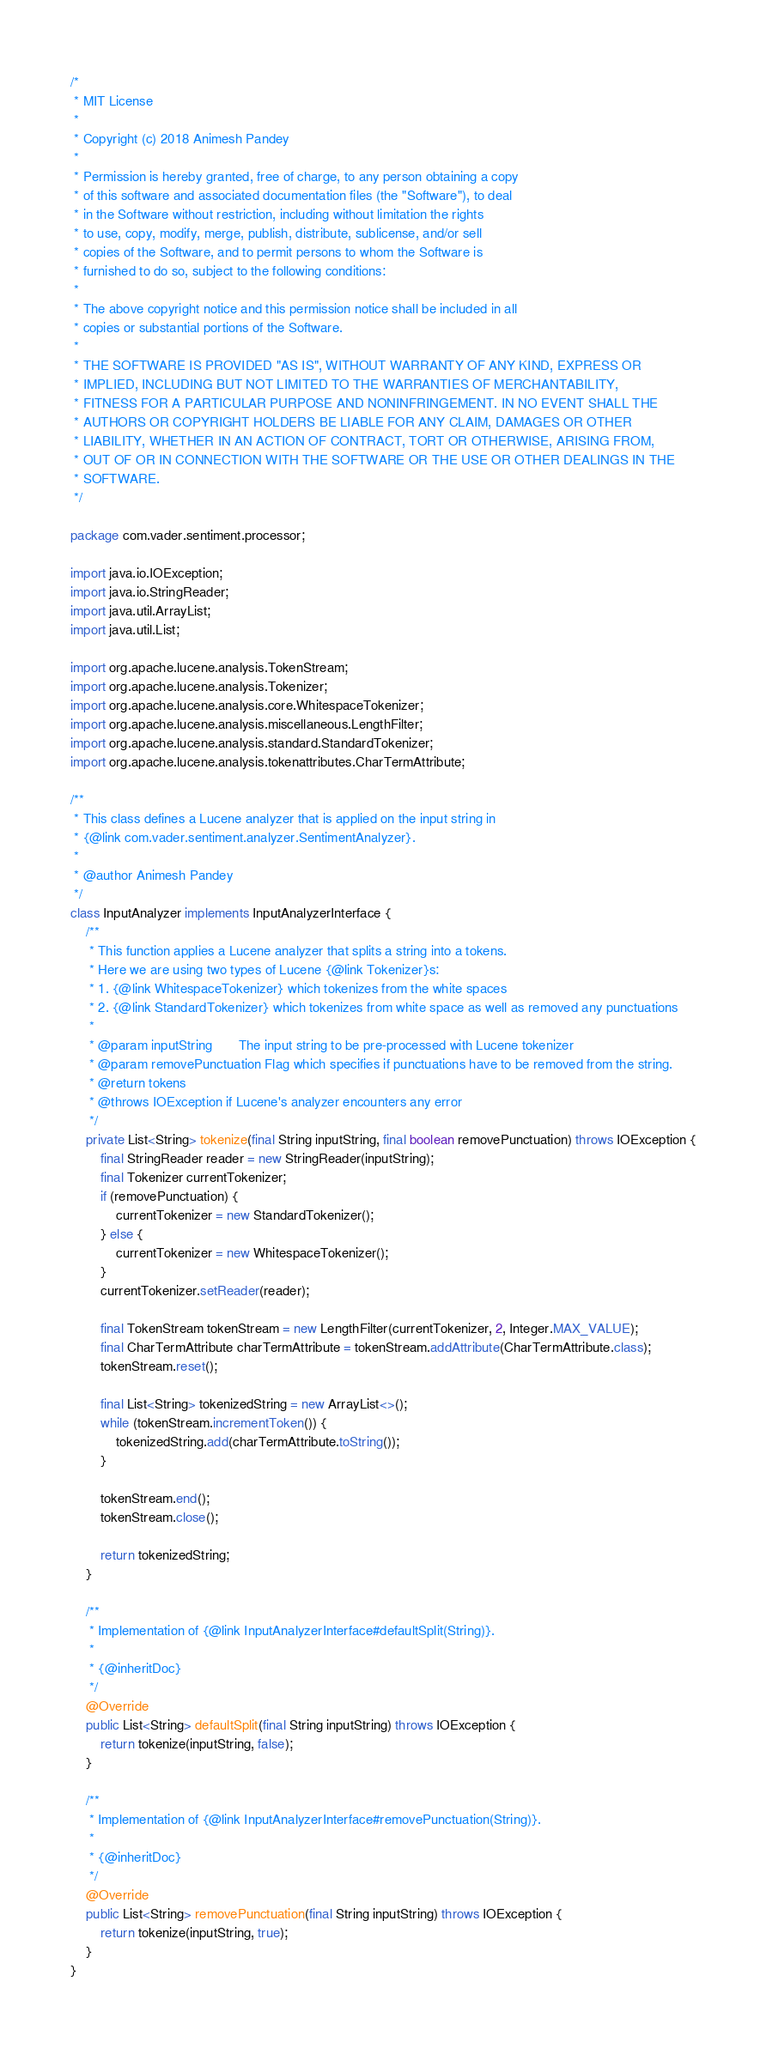<code> <loc_0><loc_0><loc_500><loc_500><_Java_>/*
 * MIT License
 *
 * Copyright (c) 2018 Animesh Pandey
 *
 * Permission is hereby granted, free of charge, to any person obtaining a copy
 * of this software and associated documentation files (the "Software"), to deal
 * in the Software without restriction, including without limitation the rights
 * to use, copy, modify, merge, publish, distribute, sublicense, and/or sell
 * copies of the Software, and to permit persons to whom the Software is
 * furnished to do so, subject to the following conditions:
 *
 * The above copyright notice and this permission notice shall be included in all
 * copies or substantial portions of the Software.
 *
 * THE SOFTWARE IS PROVIDED "AS IS", WITHOUT WARRANTY OF ANY KIND, EXPRESS OR
 * IMPLIED, INCLUDING BUT NOT LIMITED TO THE WARRANTIES OF MERCHANTABILITY,
 * FITNESS FOR A PARTICULAR PURPOSE AND NONINFRINGEMENT. IN NO EVENT SHALL THE
 * AUTHORS OR COPYRIGHT HOLDERS BE LIABLE FOR ANY CLAIM, DAMAGES OR OTHER
 * LIABILITY, WHETHER IN AN ACTION OF CONTRACT, TORT OR OTHERWISE, ARISING FROM,
 * OUT OF OR IN CONNECTION WITH THE SOFTWARE OR THE USE OR OTHER DEALINGS IN THE
 * SOFTWARE.
 */

package com.vader.sentiment.processor;

import java.io.IOException;
import java.io.StringReader;
import java.util.ArrayList;
import java.util.List;

import org.apache.lucene.analysis.TokenStream;
import org.apache.lucene.analysis.Tokenizer;
import org.apache.lucene.analysis.core.WhitespaceTokenizer;
import org.apache.lucene.analysis.miscellaneous.LengthFilter;
import org.apache.lucene.analysis.standard.StandardTokenizer;
import org.apache.lucene.analysis.tokenattributes.CharTermAttribute;

/**
 * This class defines a Lucene analyzer that is applied on the input string in
 * {@link com.vader.sentiment.analyzer.SentimentAnalyzer}.
 *
 * @author Animesh Pandey
 */
class InputAnalyzer implements InputAnalyzerInterface {
    /**
     * This function applies a Lucene analyzer that splits a string into a tokens.
     * Here we are using two types of Lucene {@link Tokenizer}s:
     * 1. {@link WhitespaceTokenizer} which tokenizes from the white spaces
     * 2. {@link StandardTokenizer} which tokenizes from white space as well as removed any punctuations
     *
     * @param inputString       The input string to be pre-processed with Lucene tokenizer
     * @param removePunctuation Flag which specifies if punctuations have to be removed from the string.
     * @return tokens
     * @throws IOException if Lucene's analyzer encounters any error
     */
    private List<String> tokenize(final String inputString, final boolean removePunctuation) throws IOException {
        final StringReader reader = new StringReader(inputString);
        final Tokenizer currentTokenizer;
        if (removePunctuation) {
            currentTokenizer = new StandardTokenizer();
        } else {
            currentTokenizer = new WhitespaceTokenizer();
        }
        currentTokenizer.setReader(reader);

        final TokenStream tokenStream = new LengthFilter(currentTokenizer, 2, Integer.MAX_VALUE);
        final CharTermAttribute charTermAttribute = tokenStream.addAttribute(CharTermAttribute.class);
        tokenStream.reset();

        final List<String> tokenizedString = new ArrayList<>();
        while (tokenStream.incrementToken()) {
            tokenizedString.add(charTermAttribute.toString());
        }

        tokenStream.end();
        tokenStream.close();

        return tokenizedString;
    }

    /**
     * Implementation of {@link InputAnalyzerInterface#defaultSplit(String)}.
     *
     * {@inheritDoc}
     */
    @Override
    public List<String> defaultSplit(final String inputString) throws IOException {
        return tokenize(inputString, false);
    }

    /**
     * Implementation of {@link InputAnalyzerInterface#removePunctuation(String)}.
     *
     * {@inheritDoc}
     */
    @Override
    public List<String> removePunctuation(final String inputString) throws IOException {
        return tokenize(inputString, true);
    }
}
</code> 